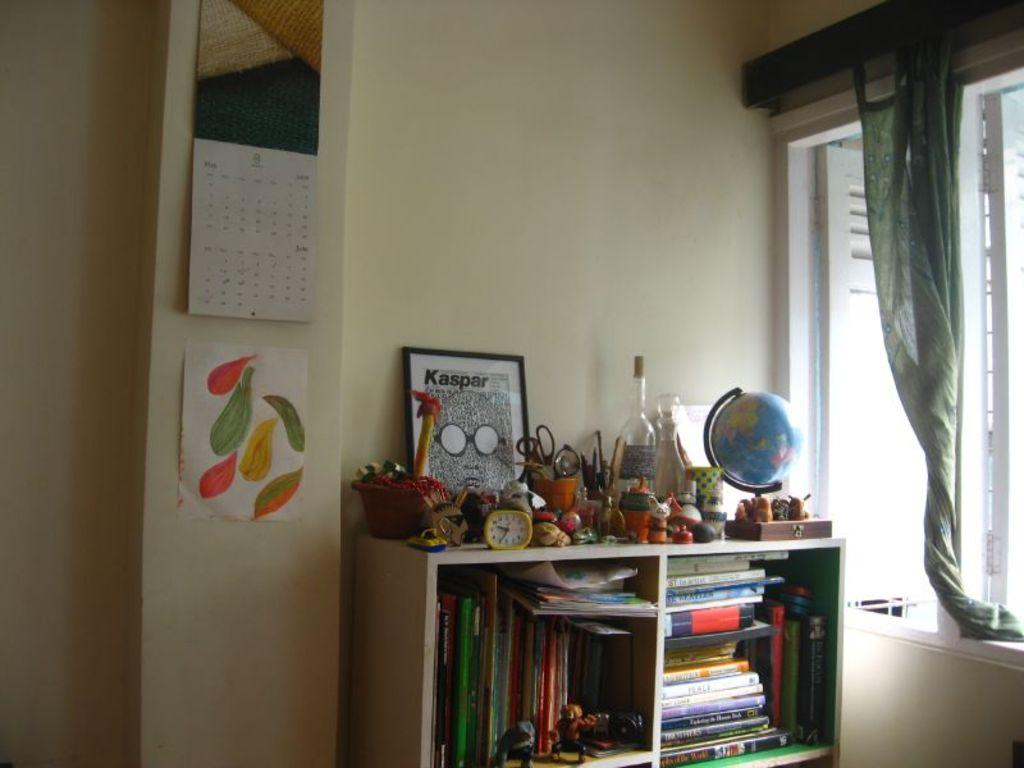<image>
Summarize the visual content of the image. A framed Kaspar print sits on a shelf in a bedroom. 